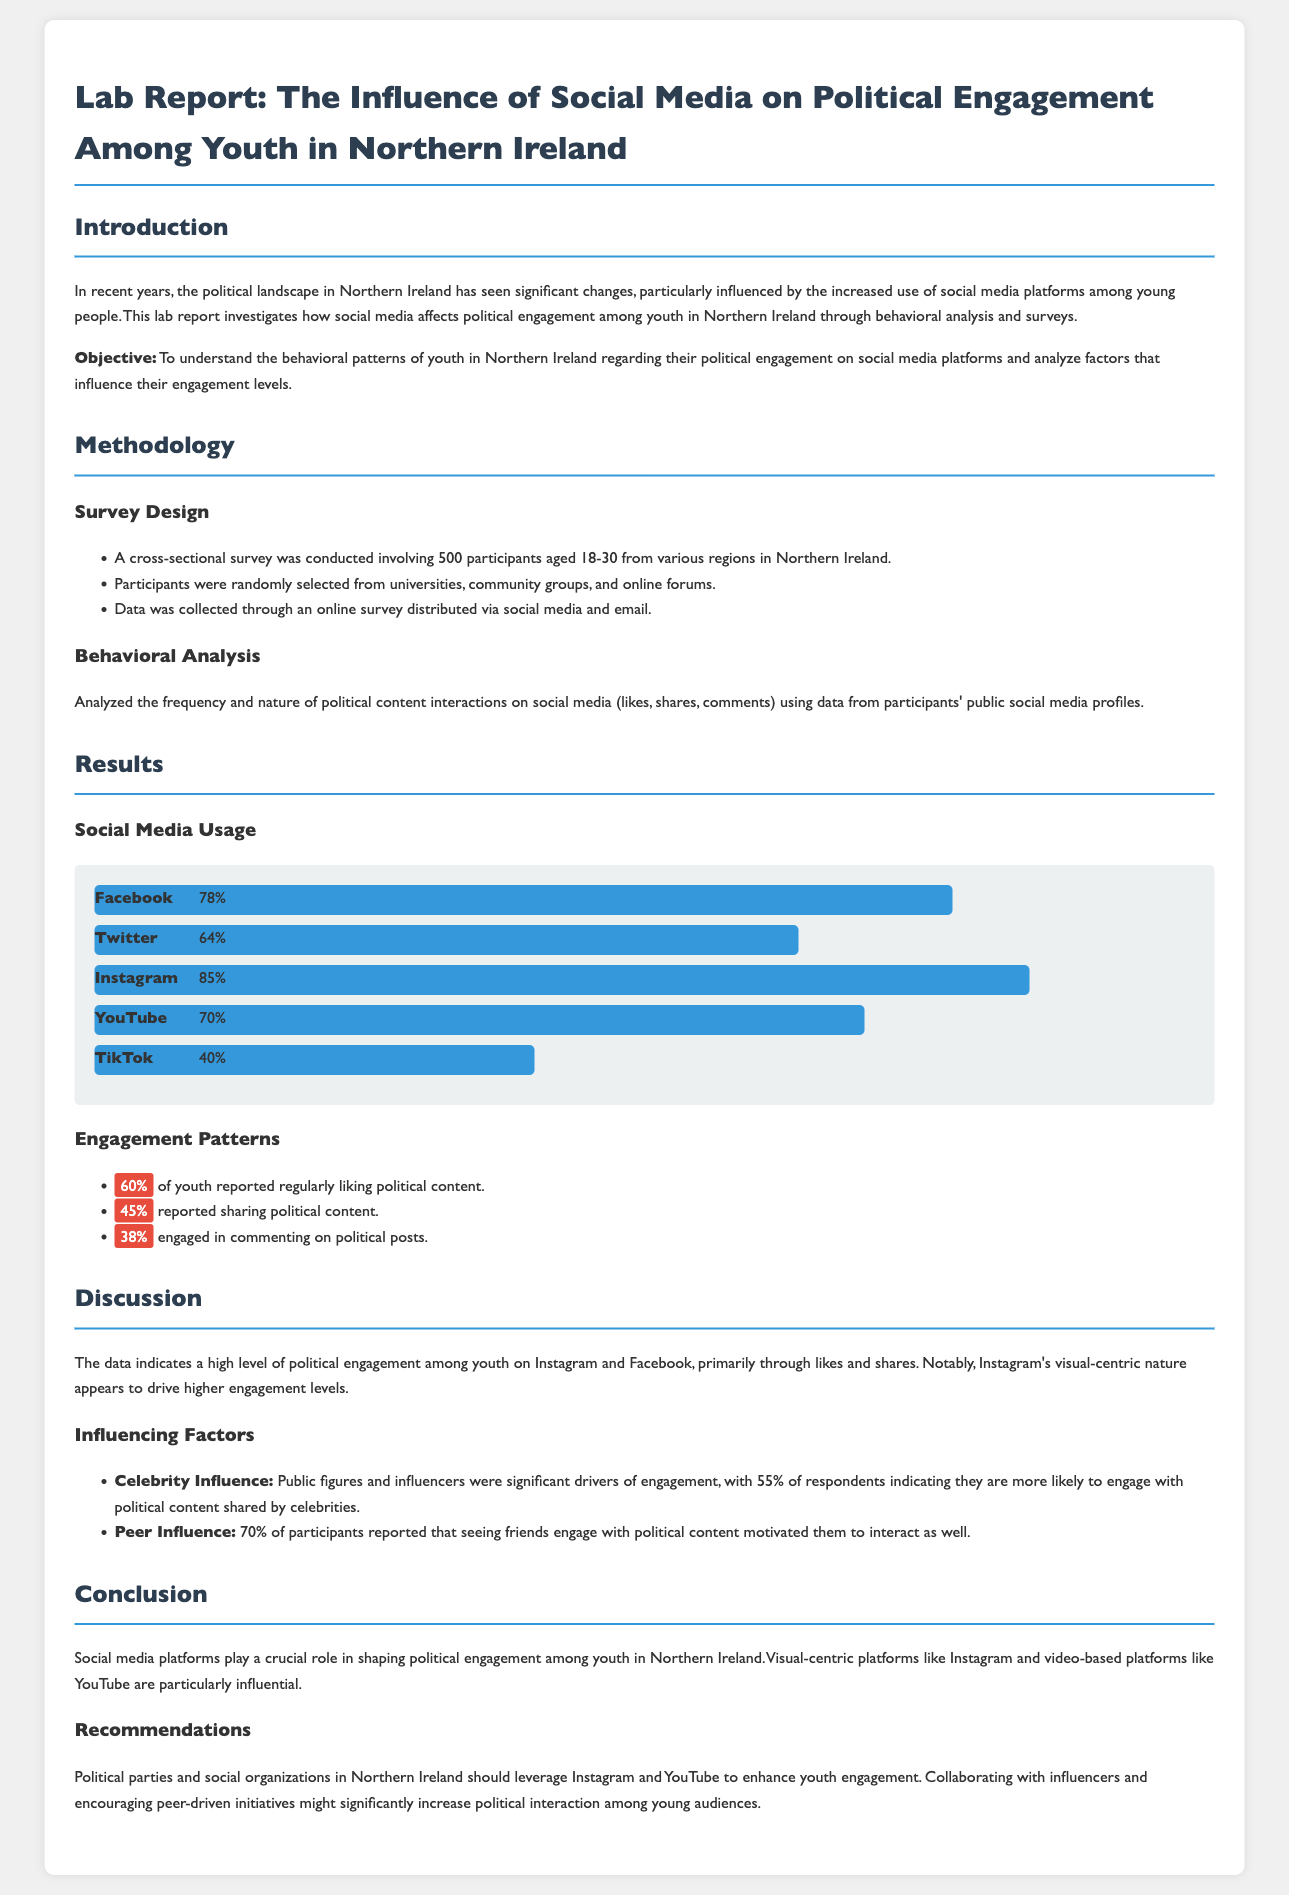What is the total number of participants in the survey? The total number of participants involved in the survey is stated in the methodology section of the report, which is 500.
Answer: 500 What percentage of youth reported regularly liking political content? The percentage of youth that regularly liked political content is provided in the results section, which states that 60% reported this behavior.
Answer: 60% Which social media platform had the highest usage among respondents? The report lists the usage percentages for various platforms in the results section, where Instagram had the highest usage at 85%.
Answer: Instagram What was the impact of celebrity influence on political engagement, according to the findings? The report indicates that 55% of respondents are more likely to engage with political content shared by celebrities, which shows the impact of celebrity influence.
Answer: 55% What type of platforms are recommended for enhancing youth engagement? The conclusion section specifies that platforms like Instagram and YouTube are recommended for enhancing youth engagement.
Answer: Instagram and YouTube What does the discussion suggest about the visual-centric nature of platforms? The discussion highlights that Instagram's visual-centric nature drives higher engagement levels among youth, emphasizing its significance.
Answer: Drives higher engagement levels What percentage of participants reported that peer influence motivated them to interact with political content? In the discussion, it is mentioned that 70% of participants reported that peer influence motivated their interactions, which is a significant finding.
Answer: 70% What is the primary objective of the lab report? The objective of the lab report is outlined in the introduction, which aims to understand behavioral patterns regarding political engagement on social media among youth in Northern Ireland.
Answer: To understand the behavioral patterns of youth What are the major categories of engagement patterns observed in youth? The engagement patterns listed in the results include liking, sharing, and commenting on political content, highlighting the ways youth interact.
Answer: Liking, sharing, commenting 